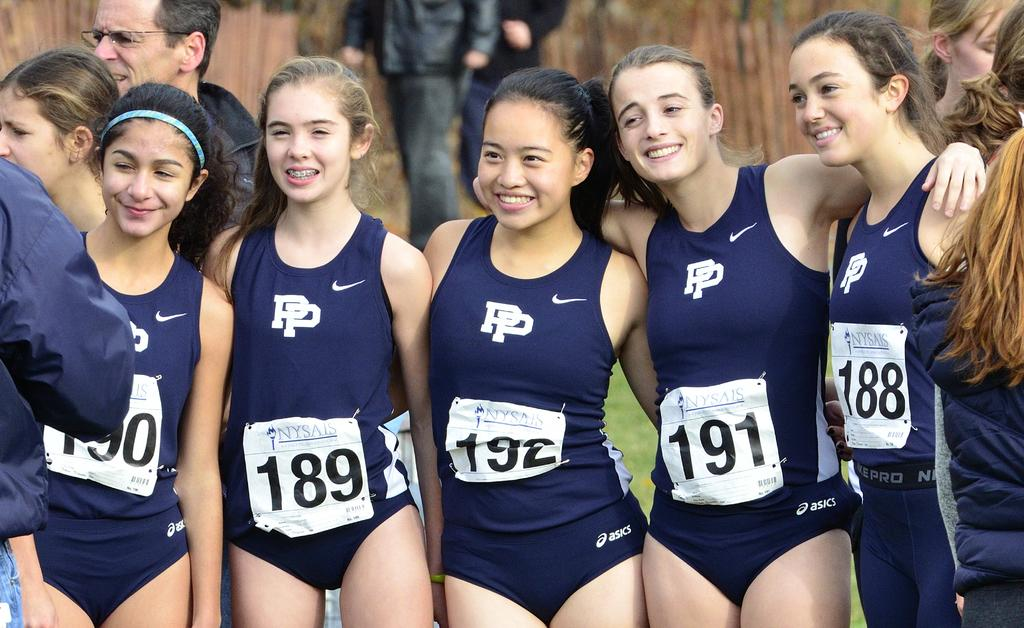<image>
Write a terse but informative summary of the picture. Some young women in bathing costumes, the one to the far right has the number 188 on her chest. 